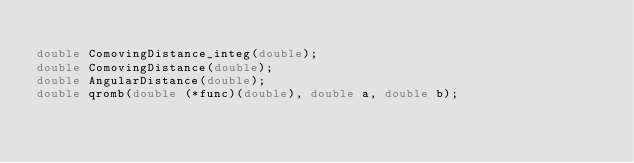<code> <loc_0><loc_0><loc_500><loc_500><_C_>
double ComovingDistance_integ(double); 
double ComovingDistance(double);
double AngularDistance(double);
double qromb(double (*func)(double), double a, double b);
</code> 